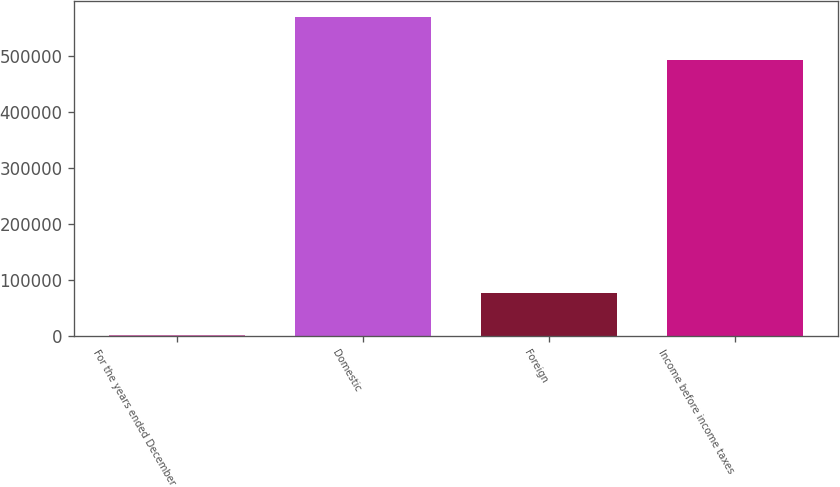Convert chart. <chart><loc_0><loc_0><loc_500><loc_500><bar_chart><fcel>For the years ended December<fcel>Domestic<fcel>Foreign<fcel>Income before income taxes<nl><fcel>2008<fcel>568282<fcel>76260<fcel>492022<nl></chart> 